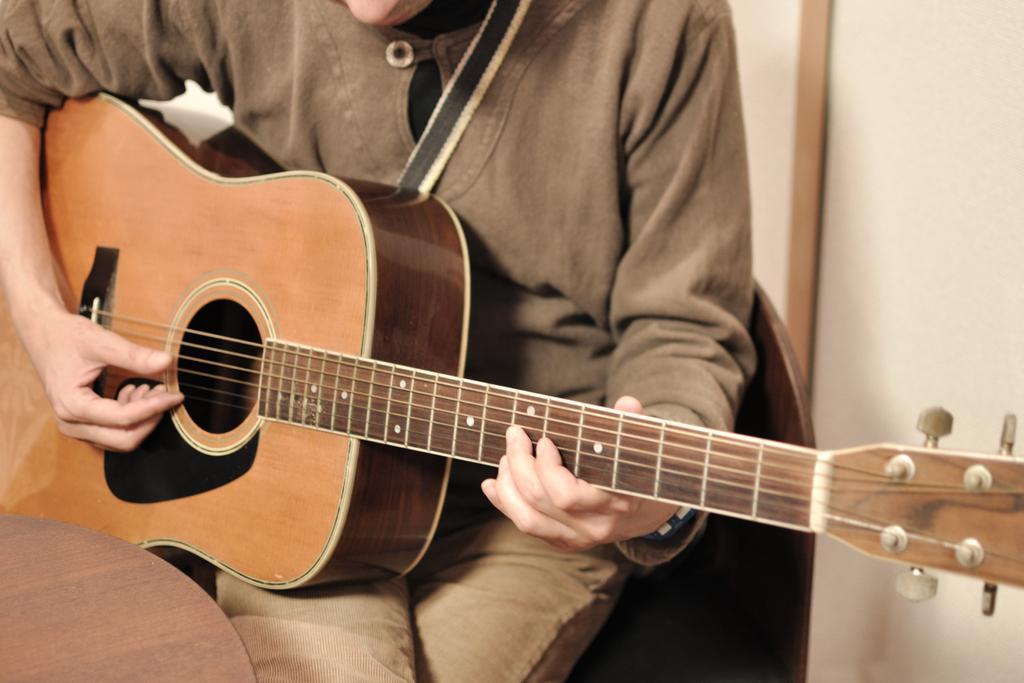Describe this image in one or two sentences. In this image, There is a boy sitting on the chair which is in brown color, He is holding a music instrument which is in yellow color, He is paying a music instrument, In the background there is a white color wall. 